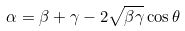Convert formula to latex. <formula><loc_0><loc_0><loc_500><loc_500>\alpha = \beta + \gamma - 2 \sqrt { \beta \gamma } \cos \theta</formula> 